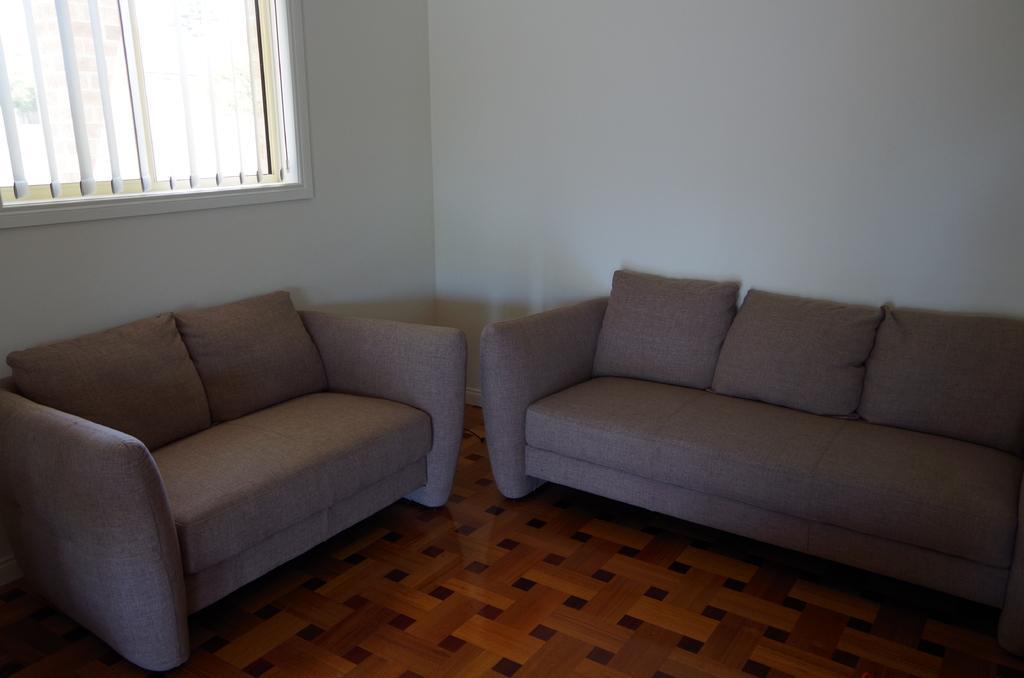In one or two sentences, can you explain what this image depicts? This picture is clicked inside a room. There are two couches in the image. In the background there is wall and window and window blinds attached to it. 